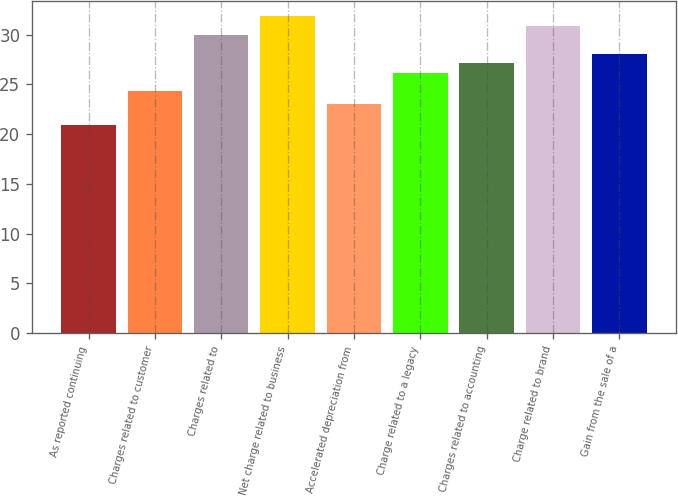Convert chart to OTSL. <chart><loc_0><loc_0><loc_500><loc_500><bar_chart><fcel>As reported continuing<fcel>Charges related to customer<fcel>Charges related to<fcel>Net charge related to business<fcel>Accelerated depreciation from<fcel>Charge related to a legacy<fcel>Charges related to accounting<fcel>Charge related to brand<fcel>Gain from the sale of a<nl><fcel>20.9<fcel>24.3<fcel>29.94<fcel>31.82<fcel>23.04<fcel>26.18<fcel>27.12<fcel>30.88<fcel>28.06<nl></chart> 